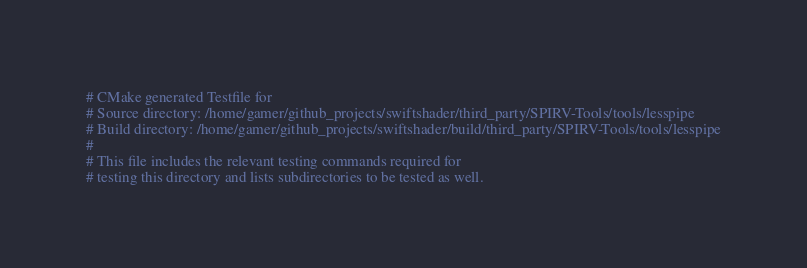<code> <loc_0><loc_0><loc_500><loc_500><_CMake_># CMake generated Testfile for 
# Source directory: /home/gamer/github_projects/swiftshader/third_party/SPIRV-Tools/tools/lesspipe
# Build directory: /home/gamer/github_projects/swiftshader/build/third_party/SPIRV-Tools/tools/lesspipe
# 
# This file includes the relevant testing commands required for 
# testing this directory and lists subdirectories to be tested as well.
</code> 